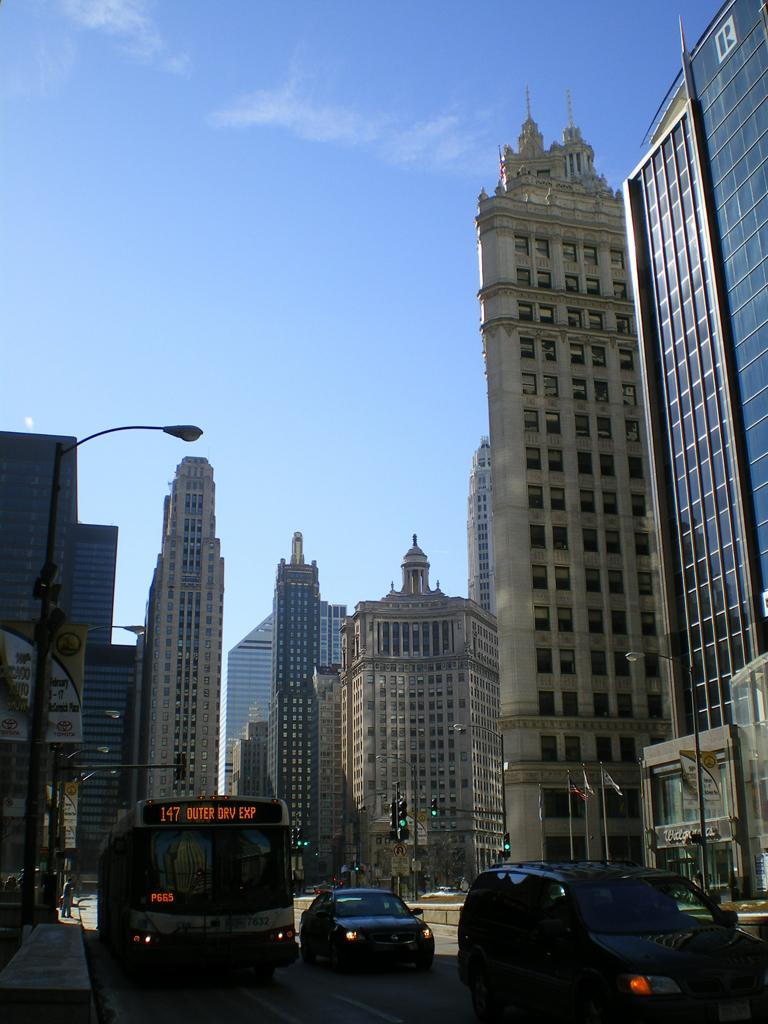What can be seen on the road in the image? There are vehicles on the road in the image. What structures are visible in the background of the image? There are light poles, traffic signals, and buildings in the background of the image. What colors are the buildings in the background? The buildings in the background are in white and brown colors. What is the color of the sky in the image? The sky is blue in the image. How many brothers are standing next to the traffic signal in the image? There are no brothers present in the image. What message of hope can be seen on the light poles in the image? There is no message of hope on the light poles in the image; they are simply light poles. 